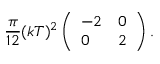<formula> <loc_0><loc_0><loc_500><loc_500>{ \frac { \pi } { 1 2 } } ( k T ) ^ { 2 } \left ( \begin{array} { l l } { - 2 } & { 0 } \\ { 0 } & { 2 } \end{array} \right ) .</formula> 